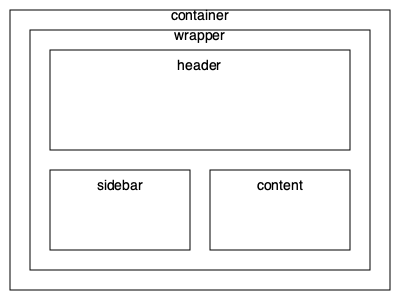Given the nested div structure shown in the image, what is the correct order of div elements from outermost to innermost? To determine the correct order of div elements from outermost to innermost, we need to analyze the nesting structure shown in the image:

1. The outermost rectangle represents the container div, as it encompasses all other elements.
2. Inside the container, we see another rectangle labeled "wrapper", which contains all other elements except the container.
3. Within the wrapper, we have three main sections:
   a. A large rectangle at the top, labeled "header".
   b. Two smaller rectangles at the bottom, labeled "sidebar" and "content".
4. The header, sidebar, and content divs are at the same nesting level, as they are all direct children of the wrapper div.

Therefore, the correct order from outermost to innermost is:
container → wrapper → (header, sidebar, content)

Note that the header, sidebar, and content divs are at the same level, so their order doesn't matter in terms of nesting.
Answer: container, wrapper, header/sidebar/content 